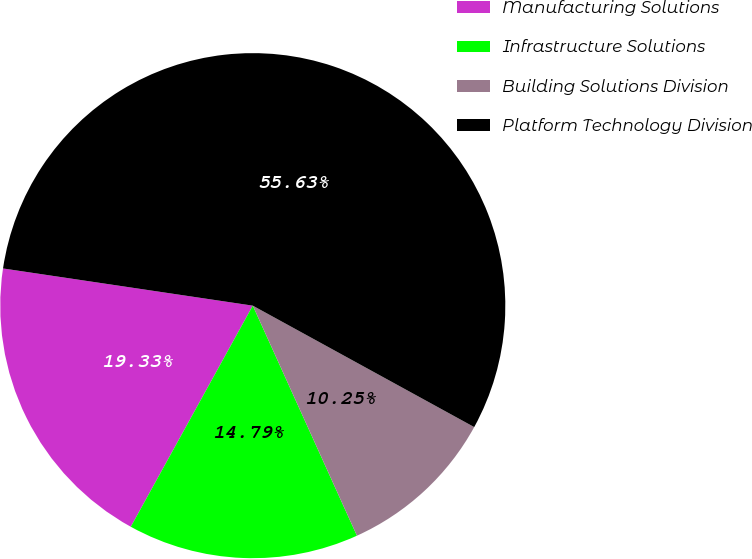<chart> <loc_0><loc_0><loc_500><loc_500><pie_chart><fcel>Manufacturing Solutions<fcel>Infrastructure Solutions<fcel>Building Solutions Division<fcel>Platform Technology Division<nl><fcel>19.33%<fcel>14.79%<fcel>10.25%<fcel>55.63%<nl></chart> 